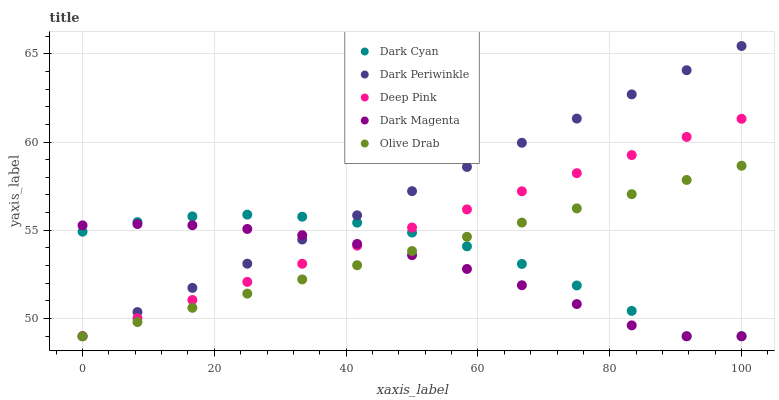Does Dark Magenta have the minimum area under the curve?
Answer yes or no. Yes. Does Dark Periwinkle have the maximum area under the curve?
Answer yes or no. Yes. Does Deep Pink have the minimum area under the curve?
Answer yes or no. No. Does Deep Pink have the maximum area under the curve?
Answer yes or no. No. Is Olive Drab the smoothest?
Answer yes or no. Yes. Is Dark Cyan the roughest?
Answer yes or no. Yes. Is Deep Pink the smoothest?
Answer yes or no. No. Is Deep Pink the roughest?
Answer yes or no. No. Does Dark Cyan have the lowest value?
Answer yes or no. Yes. Does Dark Periwinkle have the highest value?
Answer yes or no. Yes. Does Deep Pink have the highest value?
Answer yes or no. No. Does Dark Magenta intersect Deep Pink?
Answer yes or no. Yes. Is Dark Magenta less than Deep Pink?
Answer yes or no. No. Is Dark Magenta greater than Deep Pink?
Answer yes or no. No. 